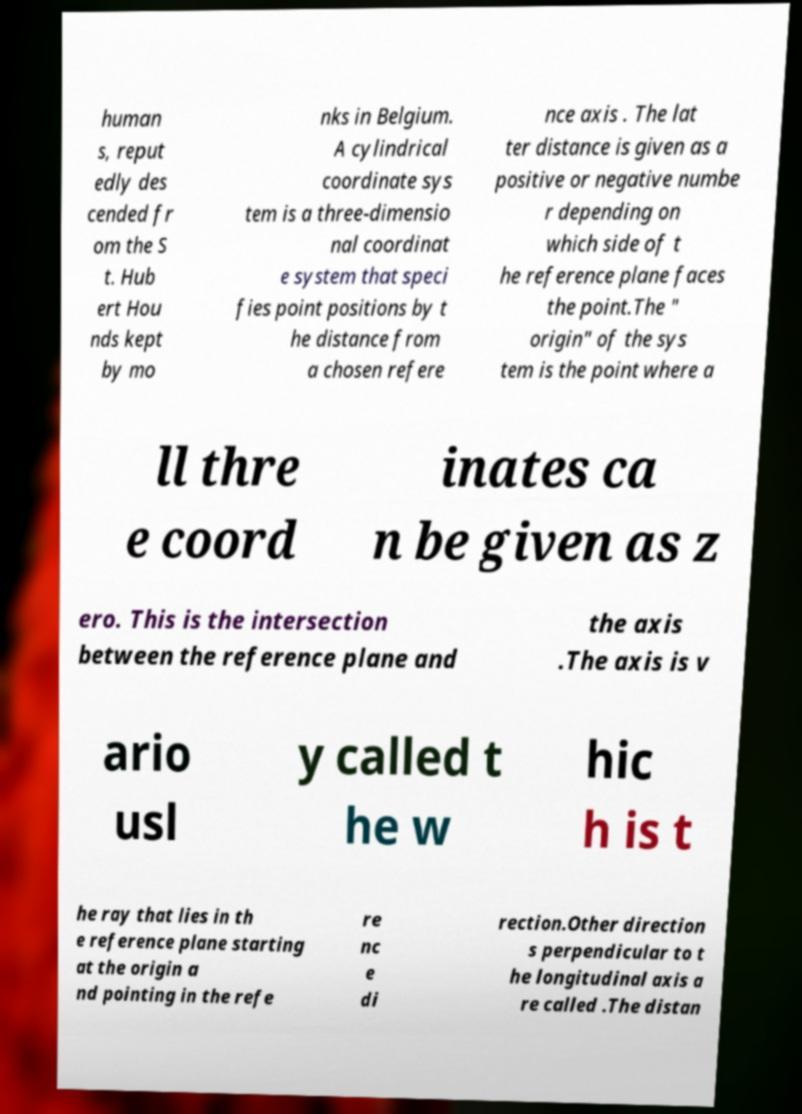There's text embedded in this image that I need extracted. Can you transcribe it verbatim? human s, reput edly des cended fr om the S t. Hub ert Hou nds kept by mo nks in Belgium. A cylindrical coordinate sys tem is a three-dimensio nal coordinat e system that speci fies point positions by t he distance from a chosen refere nce axis . The lat ter distance is given as a positive or negative numbe r depending on which side of t he reference plane faces the point.The " origin" of the sys tem is the point where a ll thre e coord inates ca n be given as z ero. This is the intersection between the reference plane and the axis .The axis is v ario usl y called t he w hic h is t he ray that lies in th e reference plane starting at the origin a nd pointing in the refe re nc e di rection.Other direction s perpendicular to t he longitudinal axis a re called .The distan 